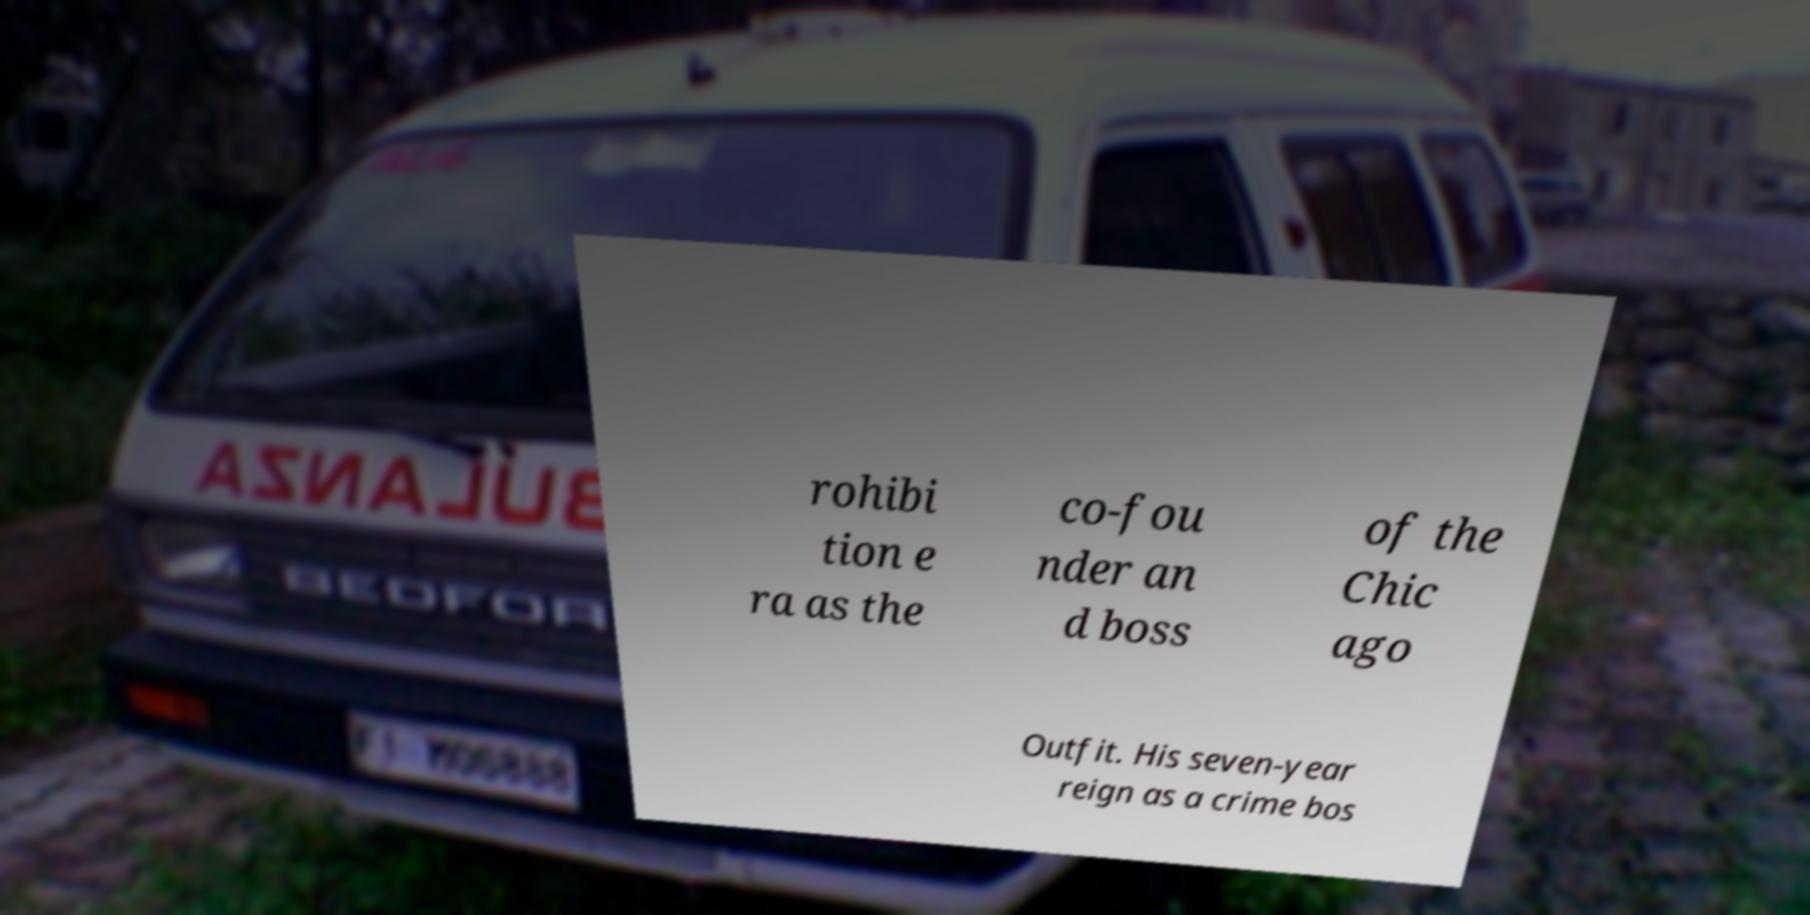There's text embedded in this image that I need extracted. Can you transcribe it verbatim? rohibi tion e ra as the co-fou nder an d boss of the Chic ago Outfit. His seven-year reign as a crime bos 